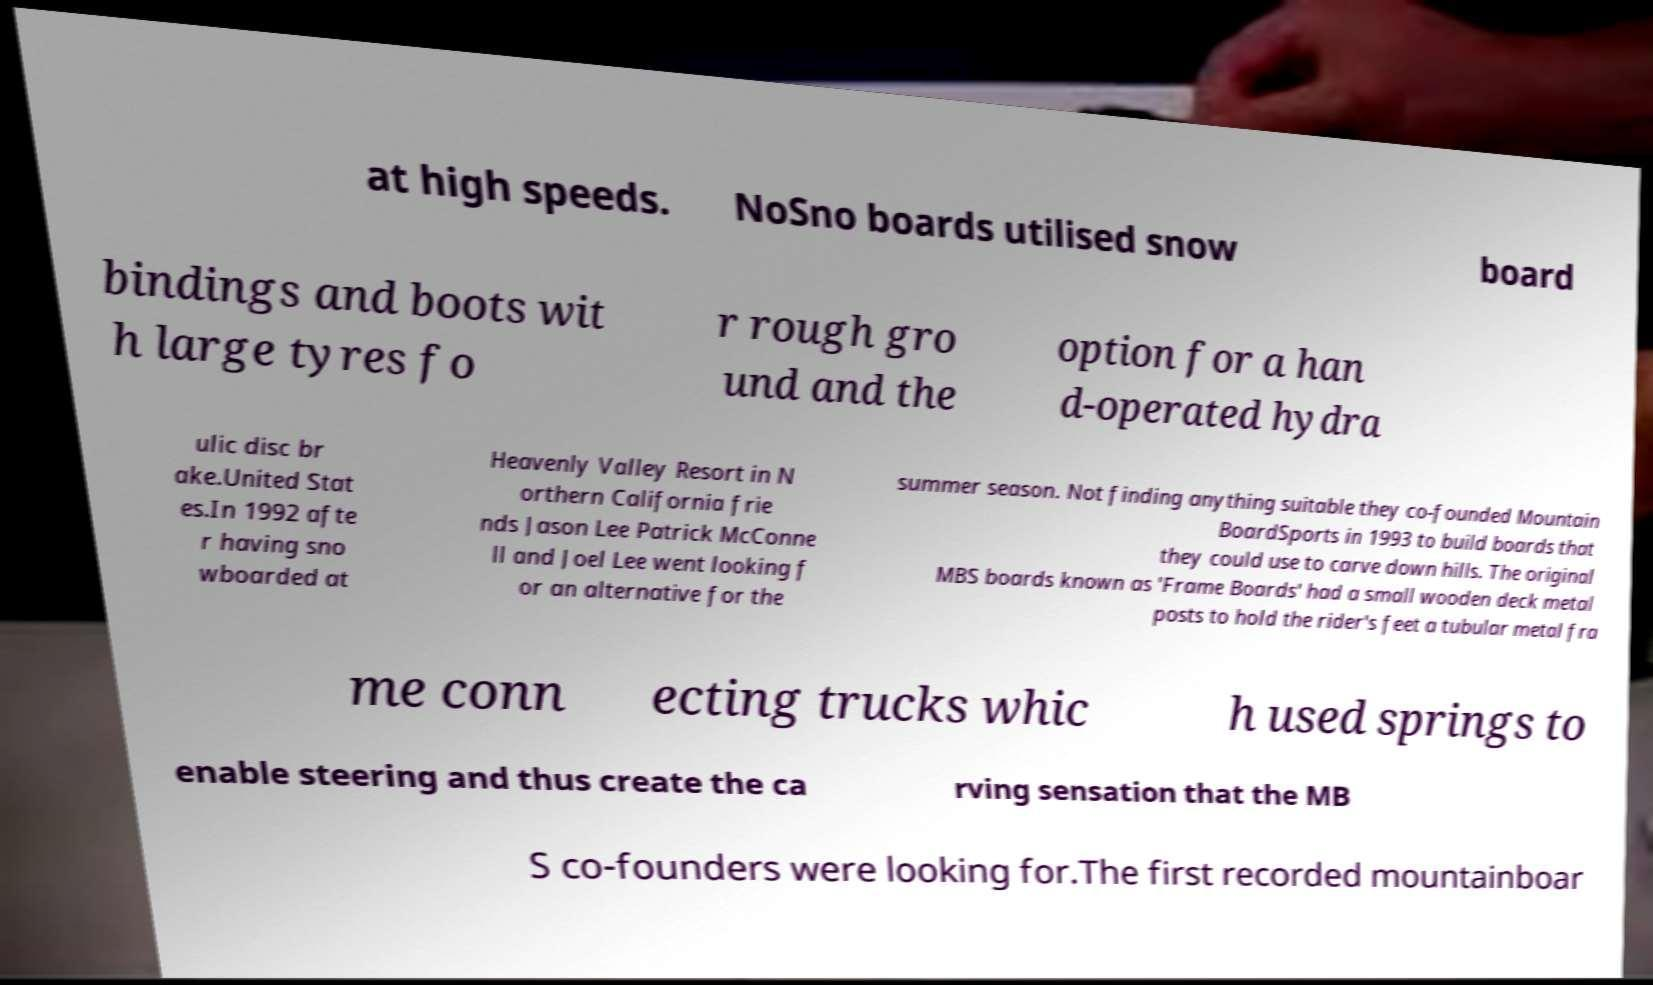Please identify and transcribe the text found in this image. at high speeds. NoSno boards utilised snow board bindings and boots wit h large tyres fo r rough gro und and the option for a han d-operated hydra ulic disc br ake.United Stat es.In 1992 afte r having sno wboarded at Heavenly Valley Resort in N orthern California frie nds Jason Lee Patrick McConne ll and Joel Lee went looking f or an alternative for the summer season. Not finding anything suitable they co-founded Mountain BoardSports in 1993 to build boards that they could use to carve down hills. The original MBS boards known as 'Frame Boards' had a small wooden deck metal posts to hold the rider's feet a tubular metal fra me conn ecting trucks whic h used springs to enable steering and thus create the ca rving sensation that the MB S co-founders were looking for.The first recorded mountainboar 